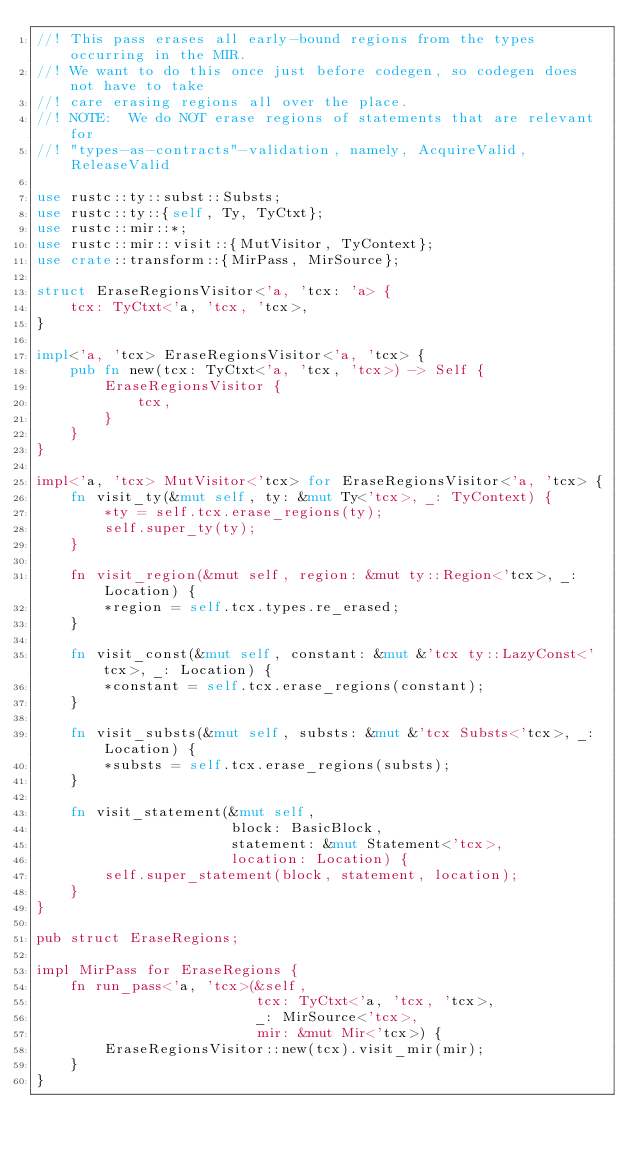Convert code to text. <code><loc_0><loc_0><loc_500><loc_500><_Rust_>//! This pass erases all early-bound regions from the types occurring in the MIR.
//! We want to do this once just before codegen, so codegen does not have to take
//! care erasing regions all over the place.
//! NOTE:  We do NOT erase regions of statements that are relevant for
//! "types-as-contracts"-validation, namely, AcquireValid, ReleaseValid

use rustc::ty::subst::Substs;
use rustc::ty::{self, Ty, TyCtxt};
use rustc::mir::*;
use rustc::mir::visit::{MutVisitor, TyContext};
use crate::transform::{MirPass, MirSource};

struct EraseRegionsVisitor<'a, 'tcx: 'a> {
    tcx: TyCtxt<'a, 'tcx, 'tcx>,
}

impl<'a, 'tcx> EraseRegionsVisitor<'a, 'tcx> {
    pub fn new(tcx: TyCtxt<'a, 'tcx, 'tcx>) -> Self {
        EraseRegionsVisitor {
            tcx,
        }
    }
}

impl<'a, 'tcx> MutVisitor<'tcx> for EraseRegionsVisitor<'a, 'tcx> {
    fn visit_ty(&mut self, ty: &mut Ty<'tcx>, _: TyContext) {
        *ty = self.tcx.erase_regions(ty);
        self.super_ty(ty);
    }

    fn visit_region(&mut self, region: &mut ty::Region<'tcx>, _: Location) {
        *region = self.tcx.types.re_erased;
    }

    fn visit_const(&mut self, constant: &mut &'tcx ty::LazyConst<'tcx>, _: Location) {
        *constant = self.tcx.erase_regions(constant);
    }

    fn visit_substs(&mut self, substs: &mut &'tcx Substs<'tcx>, _: Location) {
        *substs = self.tcx.erase_regions(substs);
    }

    fn visit_statement(&mut self,
                       block: BasicBlock,
                       statement: &mut Statement<'tcx>,
                       location: Location) {
        self.super_statement(block, statement, location);
    }
}

pub struct EraseRegions;

impl MirPass for EraseRegions {
    fn run_pass<'a, 'tcx>(&self,
                          tcx: TyCtxt<'a, 'tcx, 'tcx>,
                          _: MirSource<'tcx>,
                          mir: &mut Mir<'tcx>) {
        EraseRegionsVisitor::new(tcx).visit_mir(mir);
    }
}
</code> 